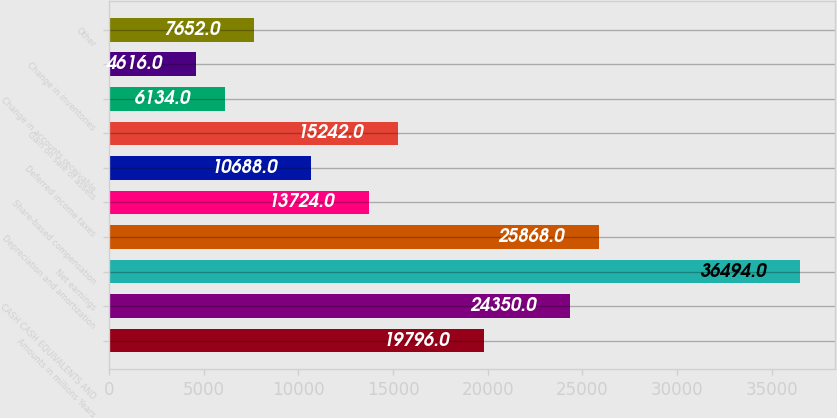<chart> <loc_0><loc_0><loc_500><loc_500><bar_chart><fcel>Amounts in millions Years<fcel>CASH CASH EQUIVALENTS AND<fcel>Net earnings<fcel>Depreciation and amortization<fcel>Share-based compensation<fcel>Deferred income taxes<fcel>Gain on sale of assets<fcel>Change in accounts receivable<fcel>Change in inventories<fcel>Other<nl><fcel>19796<fcel>24350<fcel>36494<fcel>25868<fcel>13724<fcel>10688<fcel>15242<fcel>6134<fcel>4616<fcel>7652<nl></chart> 